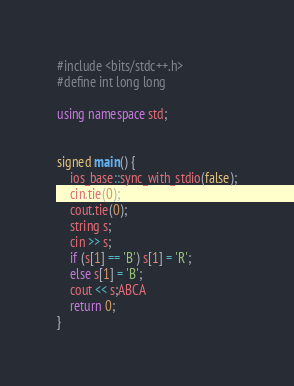<code> <loc_0><loc_0><loc_500><loc_500><_C++_>#include <bits/stdc++.h>
#define int long long

using namespace std;


signed main() {
    ios_base::sync_with_stdio(false);
    cin.tie(0);
    cout.tie(0);
    string s;
    cin >> s;
    if (s[1] == 'B') s[1] = 'R';
    else s[1] = 'B';
    cout << s;ABCA
    return 0;
}
</code> 